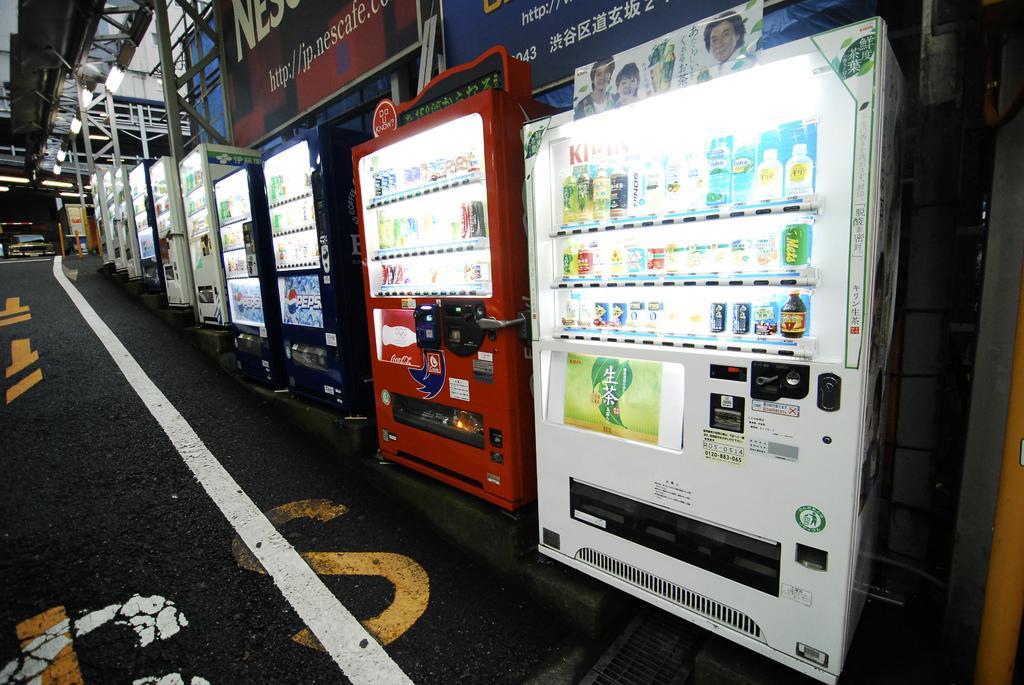How would you summarize this image in a sentence or two? In the image we can see we can see there are many vending machines of different colors and in the machines there are many other things. There is even a road and many lights. We can see there are even posters. 